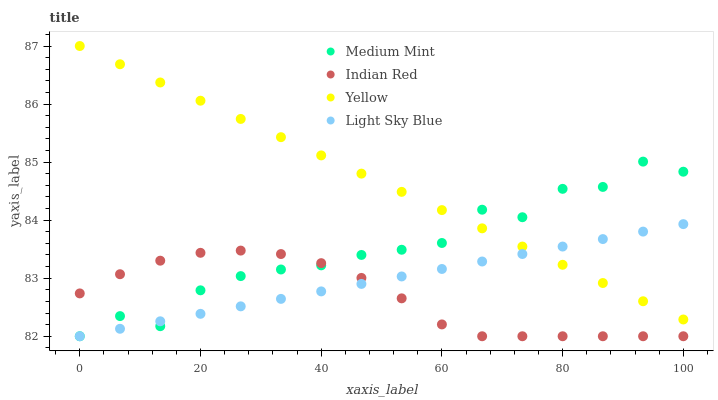Does Indian Red have the minimum area under the curve?
Answer yes or no. Yes. Does Yellow have the maximum area under the curve?
Answer yes or no. Yes. Does Light Sky Blue have the minimum area under the curve?
Answer yes or no. No. Does Light Sky Blue have the maximum area under the curve?
Answer yes or no. No. Is Light Sky Blue the smoothest?
Answer yes or no. Yes. Is Medium Mint the roughest?
Answer yes or no. Yes. Is Yellow the smoothest?
Answer yes or no. No. Is Yellow the roughest?
Answer yes or no. No. Does Medium Mint have the lowest value?
Answer yes or no. Yes. Does Yellow have the lowest value?
Answer yes or no. No. Does Yellow have the highest value?
Answer yes or no. Yes. Does Light Sky Blue have the highest value?
Answer yes or no. No. Is Indian Red less than Yellow?
Answer yes or no. Yes. Is Yellow greater than Indian Red?
Answer yes or no. Yes. Does Medium Mint intersect Indian Red?
Answer yes or no. Yes. Is Medium Mint less than Indian Red?
Answer yes or no. No. Is Medium Mint greater than Indian Red?
Answer yes or no. No. Does Indian Red intersect Yellow?
Answer yes or no. No. 